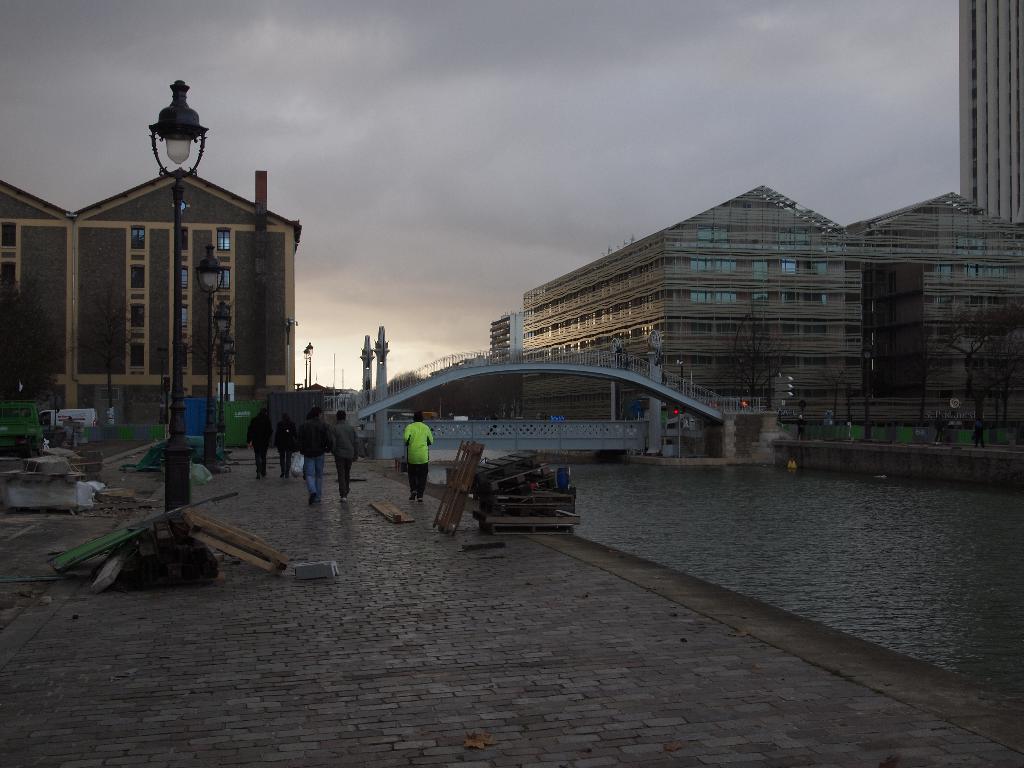Can you describe this image briefly? In this image we can see a lake, bridge and a light pole. Behind so many buildings are present. the sky is full of clouds. Left side of the image people are walking on the road. 